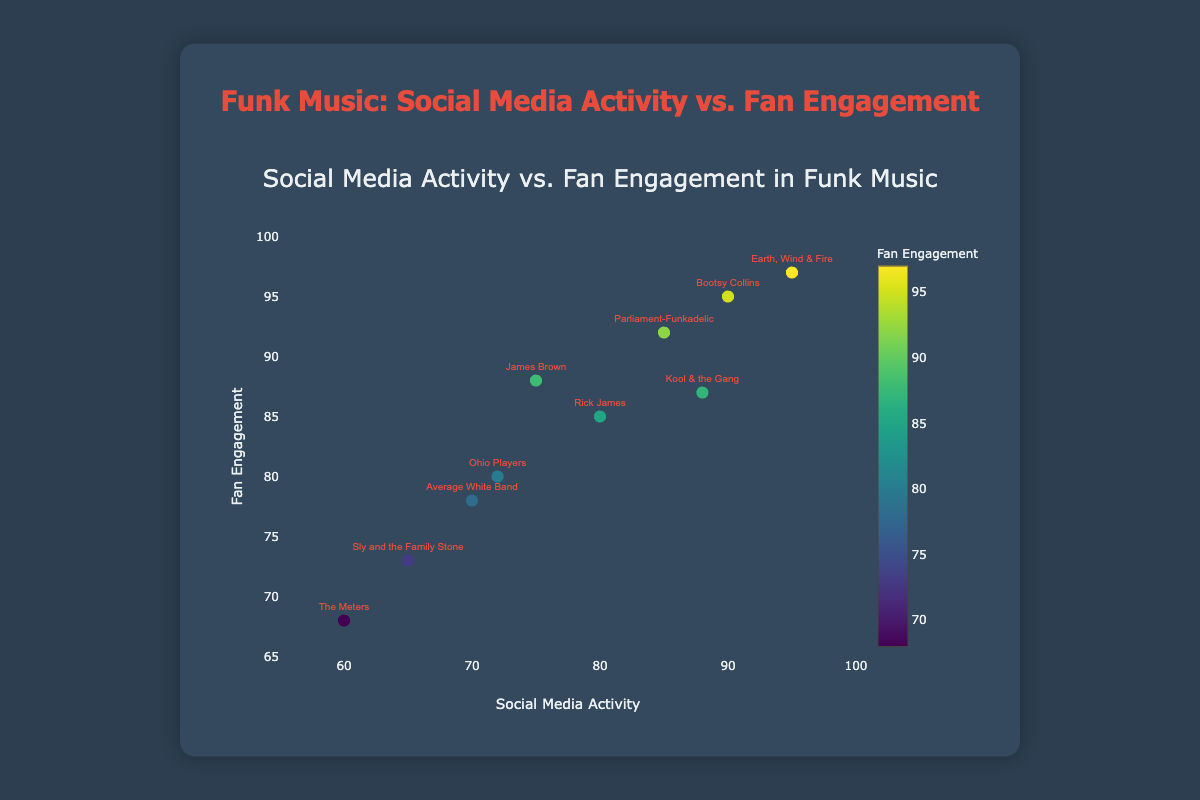What is the title of the scatter plot? The title is usually located at the top of the plot, and it provides a summary of what the plot is about. The title here is "Social Media Activity vs. Fan Engagement in Funk Music."
Answer: Social Media Activity vs. Fan Engagement in Funk Music How many data points are shown in the scatter plot? Each data point represents an artist, and there are labels for each one. Counting the artists gives us the total number of data points. There are 10 artists listed.
Answer: 10 Which artist has the highest fan engagement? The y-axis represents fan engagement, and the artist with the highest y-value will have the highest fan engagement. "Earth, Wind & Fire" has the highest fan engagement at a value of 97.
Answer: Earth, Wind & Fire Which artist has the lowest social media activity? The x-axis represents social media activity, and the artist with the lowest x-value will have the lowest social media activity. "The Meters" has the lowest social media activity at a value of 60.
Answer: The Meters Is there an artist with higher fan engagement but lower social media activity compared to "Rick James"? To answer this, we look for any data point with a y-value greater than Rick James' 85 and an x-value less than Rick James' 80. "James Brown" fits this criterion with a fan engagement of 88 and social media activity of 75.
Answer: James Brown What is the difference in social media activity between "Parliament-Funkadelic" and "Ohio Players"? Subtract the social media activity of Ohio Players from that of Parliament-Funkadelic. For Parliament-Funkadelic, it’s 85, and for Ohio Players, it’s 72. So, 85 - 72 = 13.
Answer: 13 Does any artist have equal social media activity and fan engagement? By looking at each artist's values, we check if any x and y values are identical. None of the artists have the same value for both social media activity and fan engagement.
Answer: No Which artist has the closest values for social media activity and fan engagement? To find this, compare the difference between the social media activity and fan engagement for each artist. Kool & the Gang has social media activity of 88 and fan engagement of 87, a difference of just 1.
Answer: Kool & the Gang What colors are used to represent fan engagement levels on the scatter plot markers? The colors of the markers reflect fan engagement and are part of a colorscape called 'Viridis', but the exact color values aren’t necessary to understand that higher values might be in a different color shade than lower ones. The color bar next to the plot specifies how the colors correspond to engagement levels.
Answer: 'Viridis' colorscale In general, what's the trend between social media activity and fan engagement among these artists? Observing the overall distribution of points, you can see that artists with higher social media activity also tend to have higher fan engagement, indicating a positive correlation.
Answer: Positive correlation 